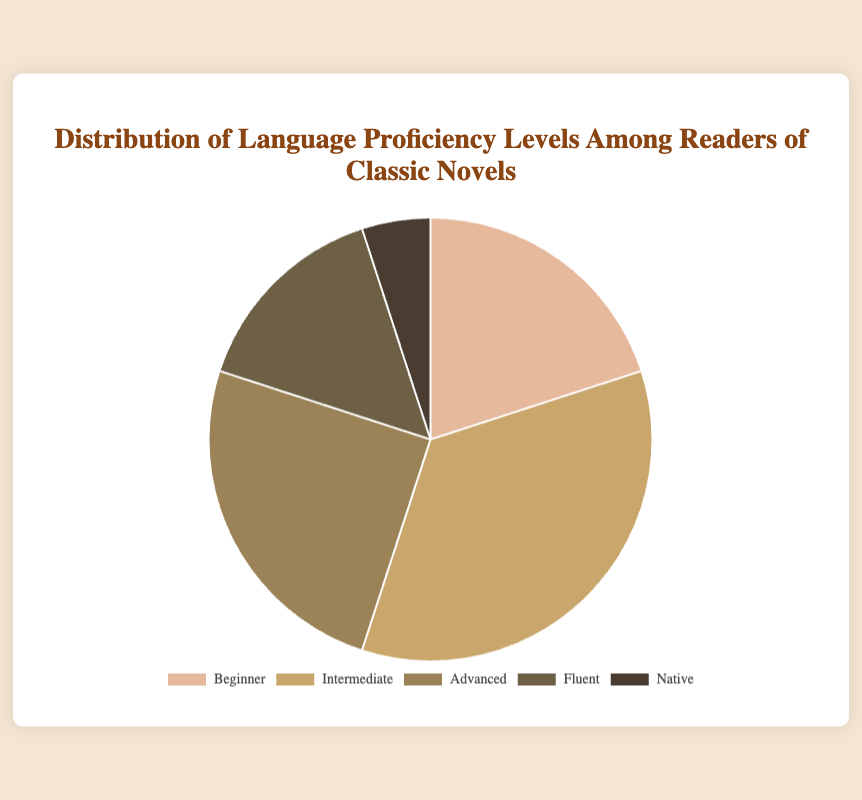What's the most common language proficiency level among readers of classic novels? The most common proficiency level can be determined by looking at the largest segment in the pie chart. The largest segment is labeled "Intermediate" with a percentage of 35%.
Answer: Intermediate Which two language proficiency levels combined make up 60% of the readers? To find the combination that makes up 60%, look at the percentages. "Intermediate" is 35% and "Advanced" is 25%, their sum is 35% + 25% = 60%.
Answer: Intermediate and Advanced What is the difference in percentage between the "Beginner" and "Native" proficiency levels? To find the difference, subtract the "Native" percentage from the "Beginner" percentage: 20% - 5% = 15%.
Answer: 15% Which color represents the "Fluent" language proficiency level on the chart? The "Fluent" section can be identified by the visual color on the pie chart, which is a darker shade compared to others, sepia.
Answer: Sepia What percentage of readers are either "Fluent" or "Native"? To find this, sum the percentages of "Fluent" and "Native": 15% + 5% = 20%.
Answer: 20% Are there more "Advanced" level readers or "Beginner" level readers, and by how much? Compare the "Advanced" percentage (25%) with the "Beginner" percentage (20%), the "Advanced" percentage is higher. The difference is 25% - 20% = 5%.
Answer: Advanced by 5% Which proficiency level has the smallest representation among readers? The smallest section in the pie chart is the "Native" proficiency level with 5%.
Answer: Native What is the combined percentage of the "Beginner" and "Intermediate" proficiency levels? Sum the percentages of "Beginner" (20%) and "Intermediate" (35%): 20% + 35% = 55%.
Answer: 55% Which proficiency level has the second-largest representation, and what percentage is it? The second-largest segment can be identified visually as "Advanced" with 25%.
Answer: Advanced, 25% How many proficiency levels have more than 20% representation? Identify the segments with more than 20%: "Beginner" (20%) does not qualify, "Intermediate" (35%) and "Advanced" (25%) both qualify, making two levels in total.
Answer: 2 